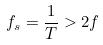<formula> <loc_0><loc_0><loc_500><loc_500>f _ { s } = \frac { 1 } { T } > 2 f</formula> 